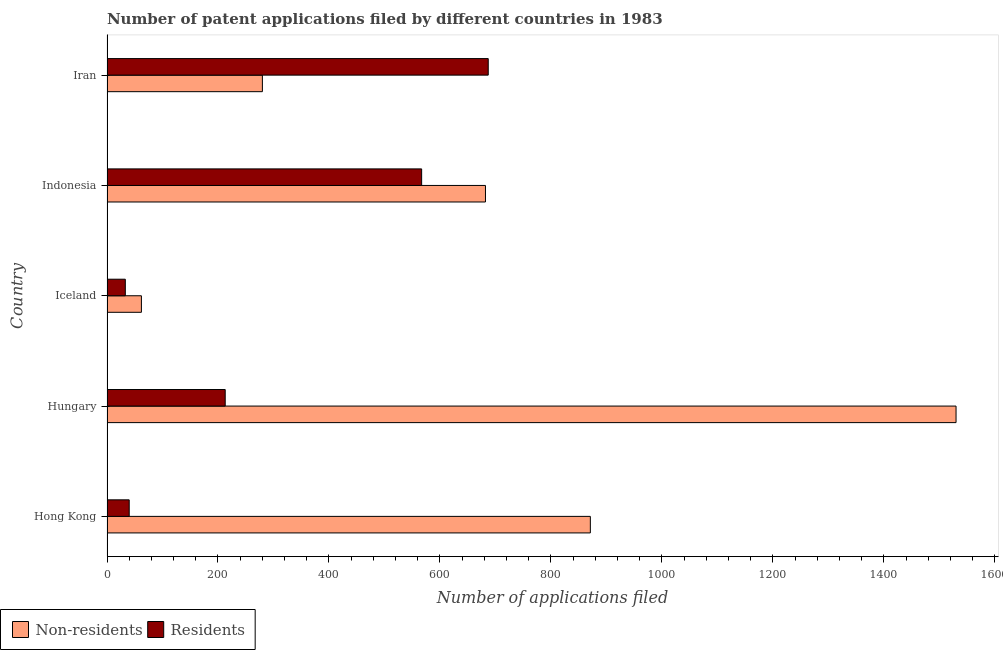How many different coloured bars are there?
Provide a short and direct response. 2. Are the number of bars per tick equal to the number of legend labels?
Provide a succinct answer. Yes. How many bars are there on the 3rd tick from the top?
Offer a very short reply. 2. What is the label of the 4th group of bars from the top?
Your response must be concise. Hungary. What is the number of patent applications by non residents in Indonesia?
Give a very brief answer. 682. Across all countries, what is the maximum number of patent applications by residents?
Your answer should be very brief. 687. Across all countries, what is the minimum number of patent applications by non residents?
Provide a short and direct response. 62. In which country was the number of patent applications by residents maximum?
Ensure brevity in your answer.  Iran. In which country was the number of patent applications by non residents minimum?
Give a very brief answer. Iceland. What is the total number of patent applications by residents in the graph?
Offer a very short reply. 1540. What is the difference between the number of patent applications by residents in Iceland and that in Iran?
Your answer should be very brief. -654. What is the difference between the number of patent applications by non residents in Hungary and the number of patent applications by residents in Hong Kong?
Your answer should be very brief. 1490. What is the average number of patent applications by residents per country?
Your answer should be compact. 308. What is the difference between the number of patent applications by residents and number of patent applications by non residents in Indonesia?
Your answer should be compact. -115. What is the ratio of the number of patent applications by residents in Indonesia to that in Iran?
Provide a short and direct response. 0.82. What is the difference between the highest and the second highest number of patent applications by residents?
Your answer should be very brief. 120. What is the difference between the highest and the lowest number of patent applications by residents?
Your answer should be very brief. 654. Is the sum of the number of patent applications by residents in Hong Kong and Iceland greater than the maximum number of patent applications by non residents across all countries?
Offer a very short reply. No. What does the 1st bar from the top in Hungary represents?
Your answer should be very brief. Residents. What does the 1st bar from the bottom in Indonesia represents?
Keep it short and to the point. Non-residents. How many bars are there?
Your answer should be compact. 10. How many countries are there in the graph?
Ensure brevity in your answer.  5. What is the difference between two consecutive major ticks on the X-axis?
Your response must be concise. 200. Where does the legend appear in the graph?
Give a very brief answer. Bottom left. What is the title of the graph?
Ensure brevity in your answer.  Number of patent applications filed by different countries in 1983. What is the label or title of the X-axis?
Keep it short and to the point. Number of applications filed. What is the Number of applications filed in Non-residents in Hong Kong?
Ensure brevity in your answer.  871. What is the Number of applications filed in Non-residents in Hungary?
Your response must be concise. 1530. What is the Number of applications filed of Residents in Hungary?
Provide a succinct answer. 213. What is the Number of applications filed in Non-residents in Iceland?
Your answer should be compact. 62. What is the Number of applications filed of Non-residents in Indonesia?
Provide a short and direct response. 682. What is the Number of applications filed of Residents in Indonesia?
Ensure brevity in your answer.  567. What is the Number of applications filed in Non-residents in Iran?
Your answer should be compact. 280. What is the Number of applications filed of Residents in Iran?
Your answer should be compact. 687. Across all countries, what is the maximum Number of applications filed of Non-residents?
Ensure brevity in your answer.  1530. Across all countries, what is the maximum Number of applications filed in Residents?
Your answer should be very brief. 687. What is the total Number of applications filed of Non-residents in the graph?
Your answer should be compact. 3425. What is the total Number of applications filed in Residents in the graph?
Offer a very short reply. 1540. What is the difference between the Number of applications filed of Non-residents in Hong Kong and that in Hungary?
Provide a short and direct response. -659. What is the difference between the Number of applications filed of Residents in Hong Kong and that in Hungary?
Your answer should be compact. -173. What is the difference between the Number of applications filed of Non-residents in Hong Kong and that in Iceland?
Keep it short and to the point. 809. What is the difference between the Number of applications filed of Residents in Hong Kong and that in Iceland?
Offer a terse response. 7. What is the difference between the Number of applications filed of Non-residents in Hong Kong and that in Indonesia?
Ensure brevity in your answer.  189. What is the difference between the Number of applications filed of Residents in Hong Kong and that in Indonesia?
Offer a very short reply. -527. What is the difference between the Number of applications filed of Non-residents in Hong Kong and that in Iran?
Your answer should be compact. 591. What is the difference between the Number of applications filed in Residents in Hong Kong and that in Iran?
Make the answer very short. -647. What is the difference between the Number of applications filed of Non-residents in Hungary and that in Iceland?
Offer a terse response. 1468. What is the difference between the Number of applications filed of Residents in Hungary and that in Iceland?
Your answer should be compact. 180. What is the difference between the Number of applications filed of Non-residents in Hungary and that in Indonesia?
Ensure brevity in your answer.  848. What is the difference between the Number of applications filed of Residents in Hungary and that in Indonesia?
Give a very brief answer. -354. What is the difference between the Number of applications filed of Non-residents in Hungary and that in Iran?
Keep it short and to the point. 1250. What is the difference between the Number of applications filed of Residents in Hungary and that in Iran?
Keep it short and to the point. -474. What is the difference between the Number of applications filed in Non-residents in Iceland and that in Indonesia?
Offer a terse response. -620. What is the difference between the Number of applications filed in Residents in Iceland and that in Indonesia?
Give a very brief answer. -534. What is the difference between the Number of applications filed of Non-residents in Iceland and that in Iran?
Your response must be concise. -218. What is the difference between the Number of applications filed in Residents in Iceland and that in Iran?
Ensure brevity in your answer.  -654. What is the difference between the Number of applications filed of Non-residents in Indonesia and that in Iran?
Keep it short and to the point. 402. What is the difference between the Number of applications filed of Residents in Indonesia and that in Iran?
Provide a short and direct response. -120. What is the difference between the Number of applications filed of Non-residents in Hong Kong and the Number of applications filed of Residents in Hungary?
Your answer should be very brief. 658. What is the difference between the Number of applications filed in Non-residents in Hong Kong and the Number of applications filed in Residents in Iceland?
Give a very brief answer. 838. What is the difference between the Number of applications filed of Non-residents in Hong Kong and the Number of applications filed of Residents in Indonesia?
Offer a very short reply. 304. What is the difference between the Number of applications filed in Non-residents in Hong Kong and the Number of applications filed in Residents in Iran?
Your answer should be very brief. 184. What is the difference between the Number of applications filed of Non-residents in Hungary and the Number of applications filed of Residents in Iceland?
Your answer should be very brief. 1497. What is the difference between the Number of applications filed in Non-residents in Hungary and the Number of applications filed in Residents in Indonesia?
Give a very brief answer. 963. What is the difference between the Number of applications filed of Non-residents in Hungary and the Number of applications filed of Residents in Iran?
Provide a short and direct response. 843. What is the difference between the Number of applications filed in Non-residents in Iceland and the Number of applications filed in Residents in Indonesia?
Offer a very short reply. -505. What is the difference between the Number of applications filed of Non-residents in Iceland and the Number of applications filed of Residents in Iran?
Provide a short and direct response. -625. What is the average Number of applications filed in Non-residents per country?
Your answer should be very brief. 685. What is the average Number of applications filed of Residents per country?
Your answer should be compact. 308. What is the difference between the Number of applications filed in Non-residents and Number of applications filed in Residents in Hong Kong?
Offer a terse response. 831. What is the difference between the Number of applications filed in Non-residents and Number of applications filed in Residents in Hungary?
Provide a short and direct response. 1317. What is the difference between the Number of applications filed of Non-residents and Number of applications filed of Residents in Indonesia?
Offer a terse response. 115. What is the difference between the Number of applications filed of Non-residents and Number of applications filed of Residents in Iran?
Make the answer very short. -407. What is the ratio of the Number of applications filed in Non-residents in Hong Kong to that in Hungary?
Give a very brief answer. 0.57. What is the ratio of the Number of applications filed of Residents in Hong Kong to that in Hungary?
Your answer should be very brief. 0.19. What is the ratio of the Number of applications filed of Non-residents in Hong Kong to that in Iceland?
Your answer should be compact. 14.05. What is the ratio of the Number of applications filed of Residents in Hong Kong to that in Iceland?
Give a very brief answer. 1.21. What is the ratio of the Number of applications filed of Non-residents in Hong Kong to that in Indonesia?
Ensure brevity in your answer.  1.28. What is the ratio of the Number of applications filed of Residents in Hong Kong to that in Indonesia?
Provide a succinct answer. 0.07. What is the ratio of the Number of applications filed in Non-residents in Hong Kong to that in Iran?
Provide a succinct answer. 3.11. What is the ratio of the Number of applications filed in Residents in Hong Kong to that in Iran?
Make the answer very short. 0.06. What is the ratio of the Number of applications filed of Non-residents in Hungary to that in Iceland?
Provide a succinct answer. 24.68. What is the ratio of the Number of applications filed of Residents in Hungary to that in Iceland?
Your answer should be very brief. 6.45. What is the ratio of the Number of applications filed of Non-residents in Hungary to that in Indonesia?
Provide a short and direct response. 2.24. What is the ratio of the Number of applications filed of Residents in Hungary to that in Indonesia?
Provide a succinct answer. 0.38. What is the ratio of the Number of applications filed in Non-residents in Hungary to that in Iran?
Your response must be concise. 5.46. What is the ratio of the Number of applications filed of Residents in Hungary to that in Iran?
Offer a terse response. 0.31. What is the ratio of the Number of applications filed of Non-residents in Iceland to that in Indonesia?
Provide a succinct answer. 0.09. What is the ratio of the Number of applications filed in Residents in Iceland to that in Indonesia?
Provide a short and direct response. 0.06. What is the ratio of the Number of applications filed of Non-residents in Iceland to that in Iran?
Provide a short and direct response. 0.22. What is the ratio of the Number of applications filed in Residents in Iceland to that in Iran?
Offer a very short reply. 0.05. What is the ratio of the Number of applications filed of Non-residents in Indonesia to that in Iran?
Your response must be concise. 2.44. What is the ratio of the Number of applications filed of Residents in Indonesia to that in Iran?
Your answer should be very brief. 0.83. What is the difference between the highest and the second highest Number of applications filed of Non-residents?
Offer a very short reply. 659. What is the difference between the highest and the second highest Number of applications filed in Residents?
Provide a short and direct response. 120. What is the difference between the highest and the lowest Number of applications filed of Non-residents?
Ensure brevity in your answer.  1468. What is the difference between the highest and the lowest Number of applications filed of Residents?
Keep it short and to the point. 654. 